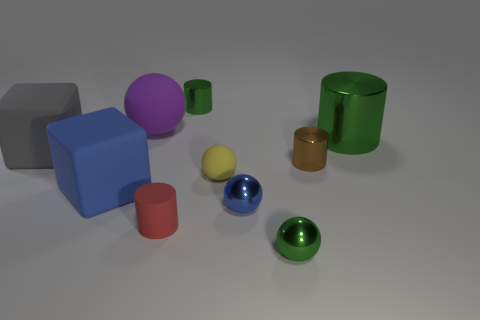There is a small red cylinder; how many yellow balls are left of it?
Give a very brief answer. 0. There is a object that is both left of the big sphere and behind the blue rubber thing; what size is it?
Your response must be concise. Large. Are there any big green cylinders?
Your answer should be very brief. Yes. What number of other objects are the same size as the brown cylinder?
Offer a very short reply. 5. There is a large matte cube on the right side of the gray cube; does it have the same color as the shiny sphere that is behind the tiny red cylinder?
Provide a succinct answer. Yes. What size is the other matte object that is the same shape as the yellow object?
Your response must be concise. Large. Is the tiny cylinder that is in front of the yellow object made of the same material as the large blue object that is behind the red rubber thing?
Give a very brief answer. Yes. How many rubber things are yellow objects or cylinders?
Offer a terse response. 2. There is a blue thing that is on the left side of the ball that is left of the cylinder behind the large cylinder; what is it made of?
Your response must be concise. Rubber. There is a blue object on the left side of the small blue object; is it the same shape as the large object that is to the left of the blue cube?
Your answer should be very brief. Yes. 